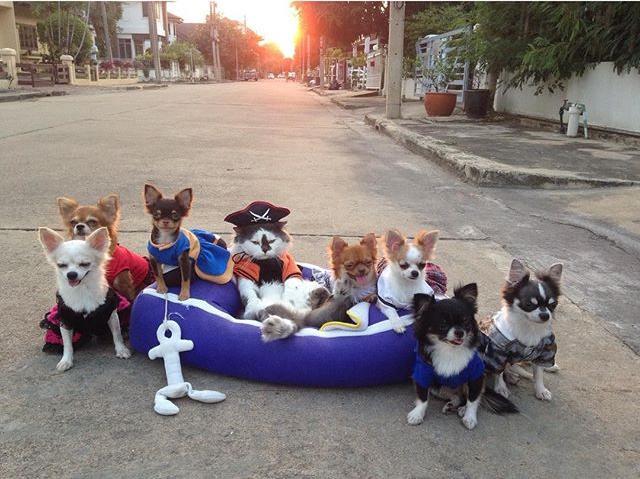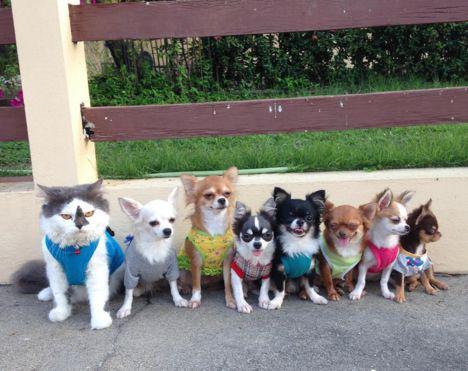The first image is the image on the left, the second image is the image on the right. Given the left and right images, does the statement "Each image shows a row of dressed dogs posing with a cat that is also wearing some garment." hold true? Answer yes or no. Yes. The first image is the image on the left, the second image is the image on the right. For the images shown, is this caption "In at least one of the images, six dogs are posing for a picture, while on a bench." true? Answer yes or no. No. 